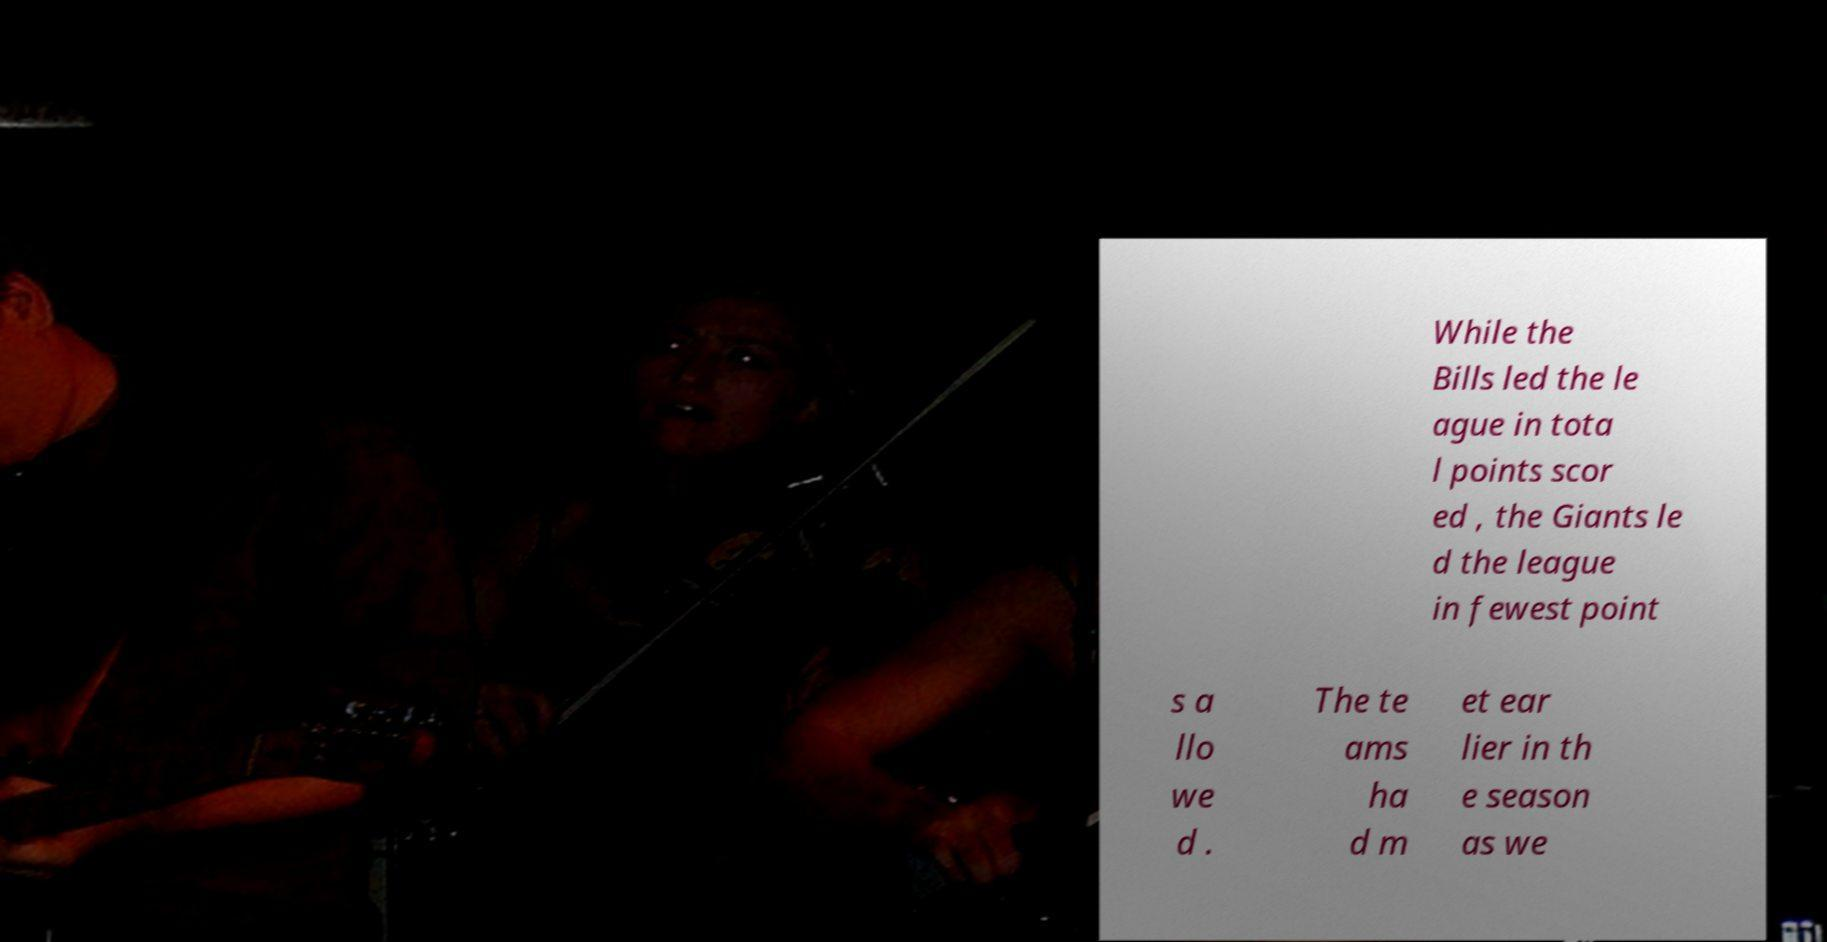There's text embedded in this image that I need extracted. Can you transcribe it verbatim? While the Bills led the le ague in tota l points scor ed , the Giants le d the league in fewest point s a llo we d . The te ams ha d m et ear lier in th e season as we 